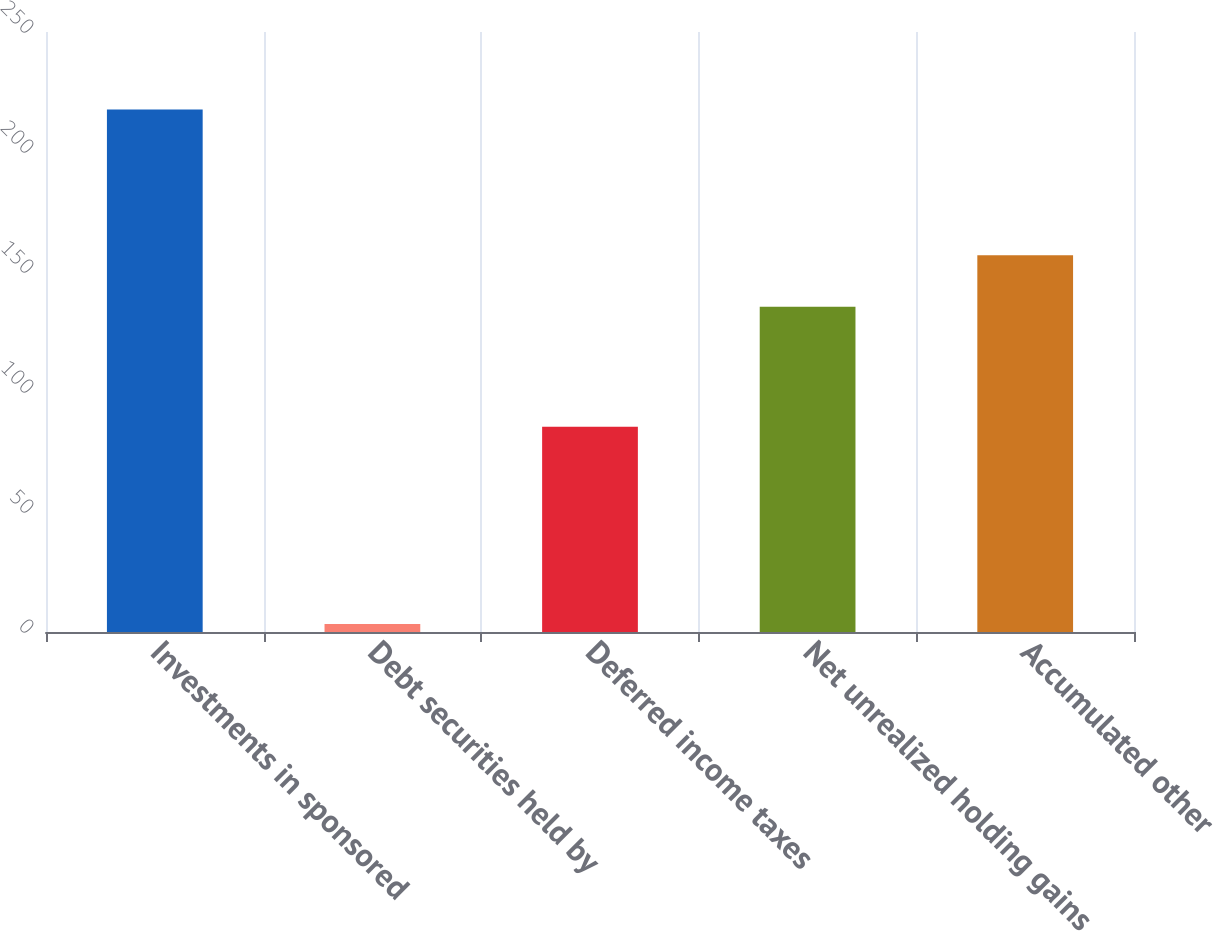<chart> <loc_0><loc_0><loc_500><loc_500><bar_chart><fcel>Investments in sponsored<fcel>Debt securities held by<fcel>Deferred income taxes<fcel>Net unrealized holding gains<fcel>Accumulated other<nl><fcel>217.7<fcel>3.3<fcel>85.5<fcel>135.5<fcel>156.94<nl></chart> 